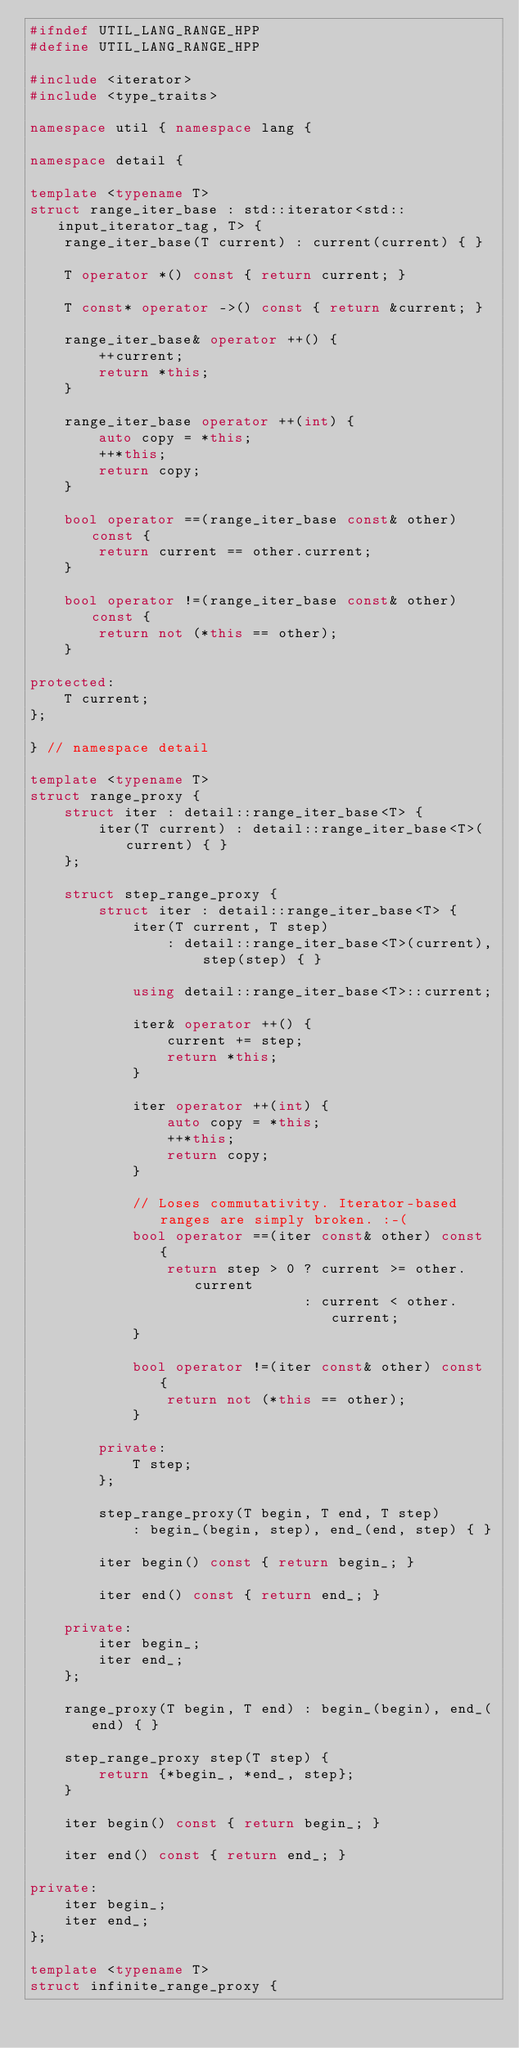<code> <loc_0><loc_0><loc_500><loc_500><_C++_>#ifndef UTIL_LANG_RANGE_HPP
#define UTIL_LANG_RANGE_HPP

#include <iterator>
#include <type_traits>

namespace util { namespace lang {

namespace detail {

template <typename T>
struct range_iter_base : std::iterator<std::input_iterator_tag, T> {
    range_iter_base(T current) : current(current) { }

    T operator *() const { return current; }

    T const* operator ->() const { return &current; }

    range_iter_base& operator ++() {
        ++current;
        return *this;
    }

    range_iter_base operator ++(int) {
        auto copy = *this;
        ++*this;
        return copy;
    }

    bool operator ==(range_iter_base const& other) const {
        return current == other.current;
    }

    bool operator !=(range_iter_base const& other) const {
        return not (*this == other);
    }

protected:
    T current;
};

} // namespace detail

template <typename T>
struct range_proxy {
    struct iter : detail::range_iter_base<T> {
        iter(T current) : detail::range_iter_base<T>(current) { }
    };

    struct step_range_proxy {
        struct iter : detail::range_iter_base<T> {
            iter(T current, T step)
                : detail::range_iter_base<T>(current), step(step) { }

            using detail::range_iter_base<T>::current;

            iter& operator ++() {
                current += step;
                return *this;
            }

            iter operator ++(int) {
                auto copy = *this;
                ++*this;
                return copy;
            }

            // Loses commutativity. Iterator-based ranges are simply broken. :-(
            bool operator ==(iter const& other) const {
                return step > 0 ? current >= other.current
                                : current < other.current;
            }

            bool operator !=(iter const& other) const {
                return not (*this == other);
            }

        private:
            T step;
        };

        step_range_proxy(T begin, T end, T step)
            : begin_(begin, step), end_(end, step) { }

        iter begin() const { return begin_; }

        iter end() const { return end_; }

    private:
        iter begin_;
        iter end_;
    };

    range_proxy(T begin, T end) : begin_(begin), end_(end) { }

    step_range_proxy step(T step) {
        return {*begin_, *end_, step};
    }

    iter begin() const { return begin_; }

    iter end() const { return end_; }

private:
    iter begin_;
    iter end_;
};

template <typename T>
struct infinite_range_proxy {</code> 